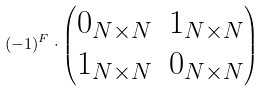<formula> <loc_0><loc_0><loc_500><loc_500>( - 1 ) ^ { F } \cdot \begin{pmatrix} 0 _ { N \times N } & 1 _ { N \times N } \\ 1 _ { N \times N } & 0 _ { N \times N } \end{pmatrix}</formula> 